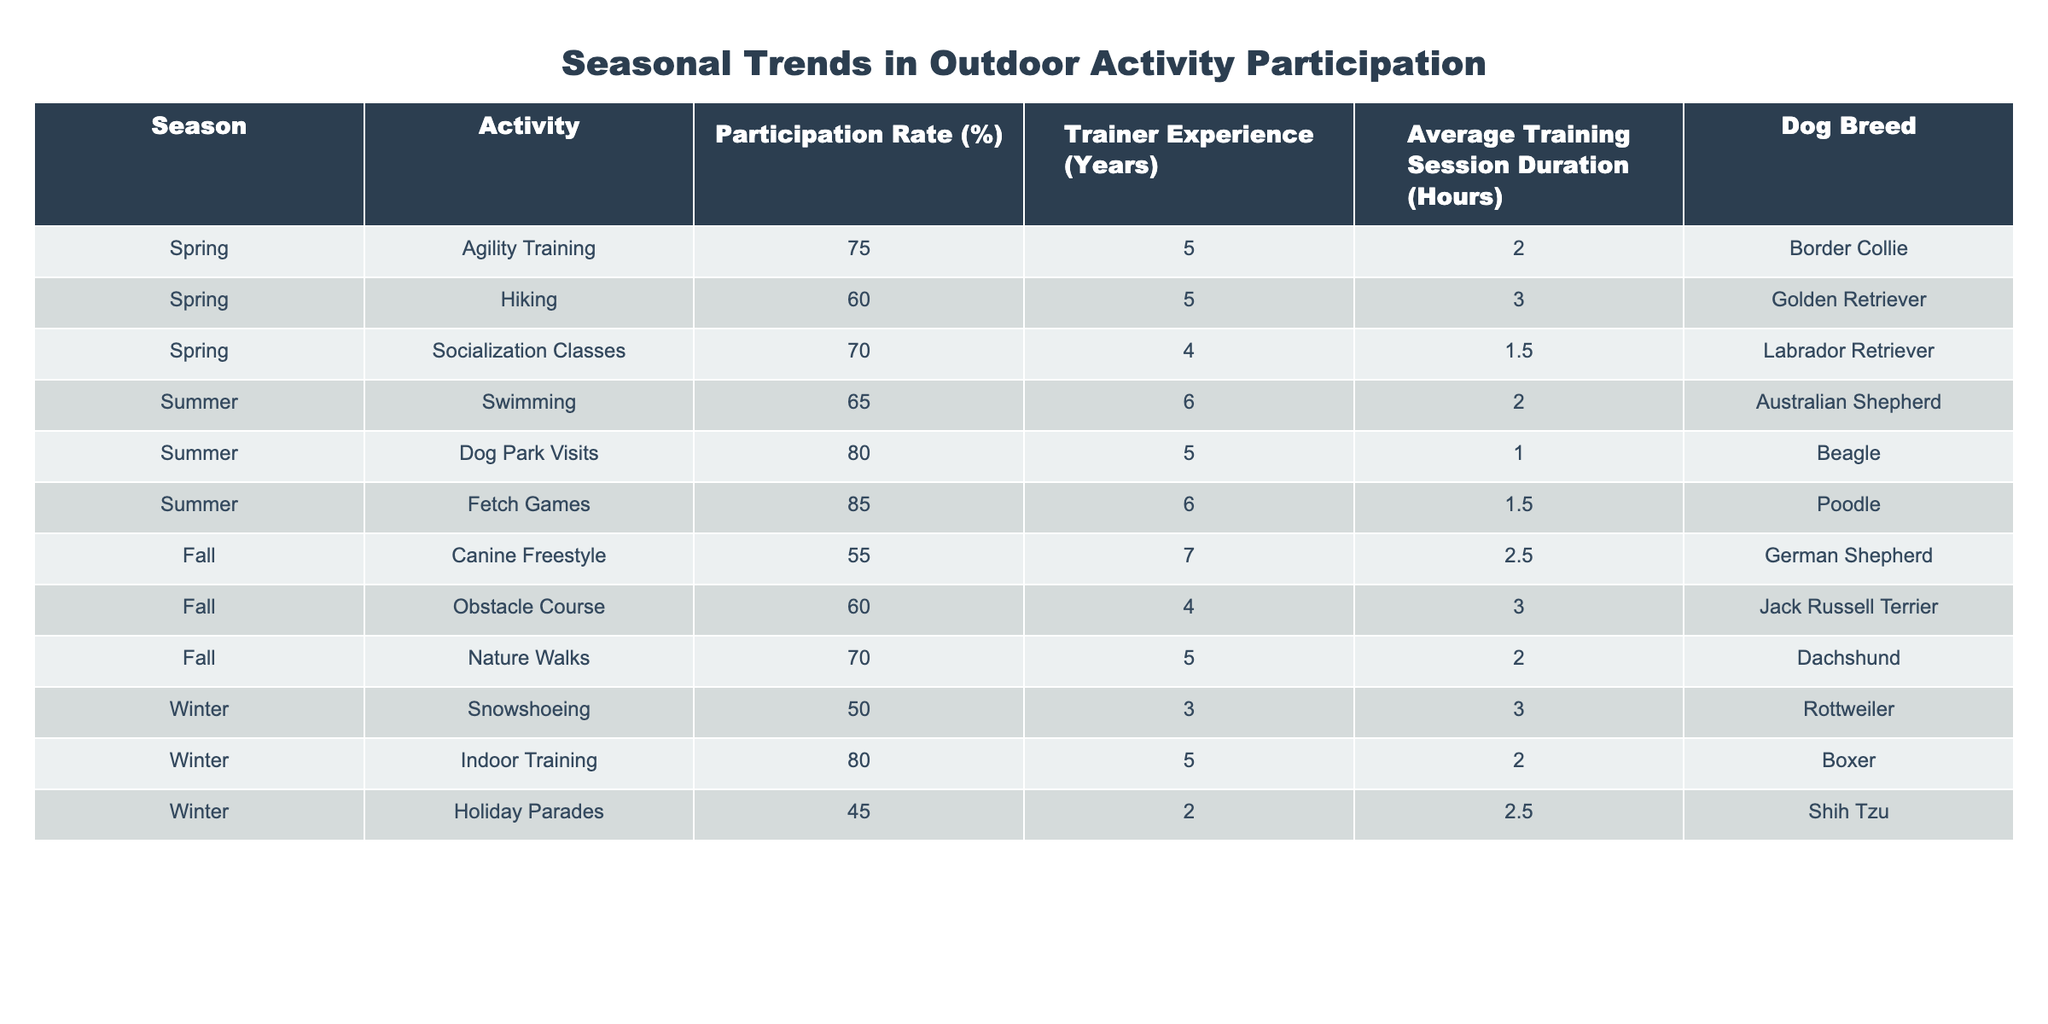What is the participation rate for Agility Training in Spring? The table shows that Agility Training has a participation rate of 75% in Spring.
Answer: 75% Which activity has the highest participation rate in Summer? From the table, Fetch Games has the highest participation rate in Summer at 85%.
Answer: 85% What is the average participation rate for Winter activities? The Winter activities have participation rates of 50% (Snowshoeing), 80% (Indoor Training), and 45% (Holiday Parades). Summing these gives 50 + 80 + 45 = 175. There are 3 Winter activities, so the average is 175/3 = 58.33.
Answer: 58.33% Is there a difference in participation rates between Fall and Winter activities? In Fall, the participation rates are 55% (Canine Freestyle), 60% (Obstacle Course), and 70% (Nature Walks) resulting in an average of (55 + 60 + 70) / 3 = 61.67%. In Winter, the average participation rate is 58.33%. The difference is 61.67% - 58.33% = 3.34%.
Answer: Yes, Fall has a higher average by 3.34% Which dog breed participates in the highest number of activities throughout the year? The table shows Border Collie participates in 1 (Agility Training) in Spring, Golden Retriever in 1 (Hiking) in Spring, Labrador Retriever in 1 (Socialization Classes) in Spring, and so on for each breed. To find the dog breed participating in the highest number of activities, we check that no breed repeats across the activities, resulting in all breeds participating in only one event. Thus, all of them have an equal count of 1.
Answer: None, each breed participates in 1 unique activity What is the participation rate of the Boxer in Winter's Indoor Training? According to the table, the participation rate for Indoor Training with Boxer is 80%.
Answer: 80% Which season has the lowest participation rate for outdoor activities? The table outlines participation rates for each season: Spring (75%, 60%, 70%), Summer (65%, 80%, 85%), Fall (55%, 60%, 70%), and Winter (50%, 80%, 45%). The average participation for each season shows Fall has the lowest average participation rate of (55 + 60 + 70) / 3 = 61.67%.
Answer: Fall Is there any activity in which a dog breed with more than 5 years of trainer experience has the highest participation rate? Looking through the table, the highest participation rates for activities with trainers having more than 5 years of experience are observed: Summer - Fetch Games (85%) with 6 years, and Spring - Agility Training (75%) with 5 years. There is no activity with trainer experience above 5 years surpassing the 85% participation with Fetch Games being the highest.
Answer: No, Fetch Games is the highest 